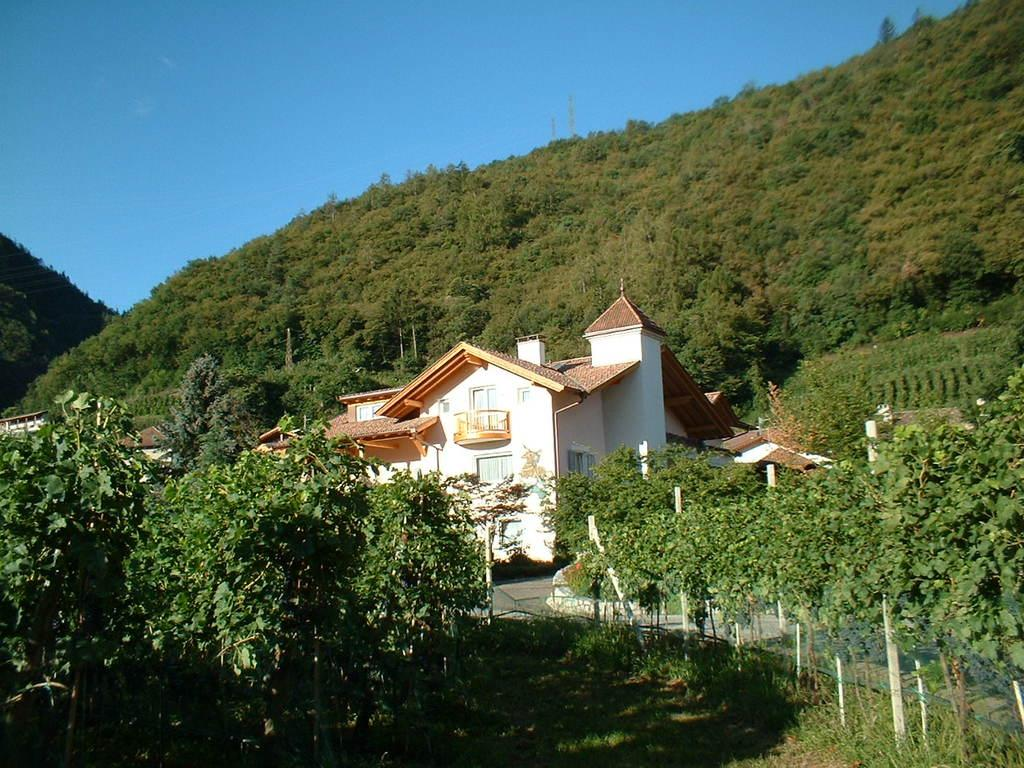What type of vegetation is present on the ground in the center of the image? There is grass on the ground in the center of the image. What other types of vegetation can be seen in the image? There are plants in the image. What type of structure is visible in the image? There is a home in the image. Where are the houses located in the image? There are houses on the left side of the image. What can be seen in the background of the image? There are trees in the background of the image. What is the name of the leather pail used to water the plants in the image? There is no leather pail present in the image, and therefore no name can be given. 